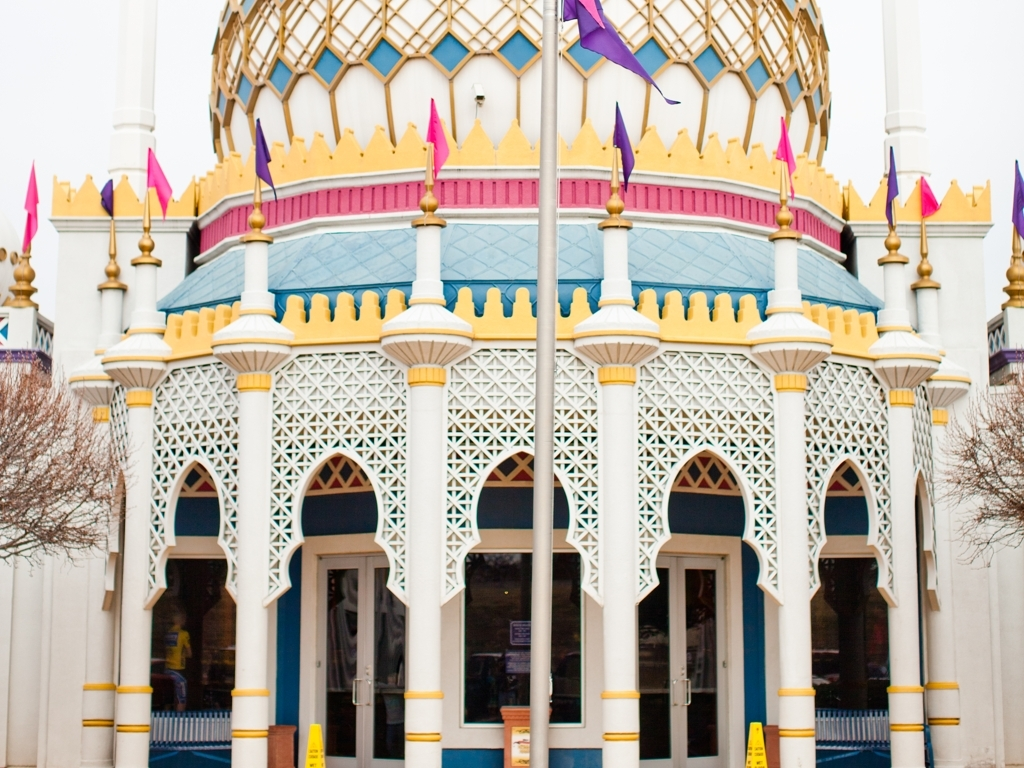Is there any indication of the building's function or context? While the image doesn't provide explicit context, the whimsical design and bright colors may indicate that this building is part of a theme park or cultural center designed to attract visitors and evoke a sense of wonder. 